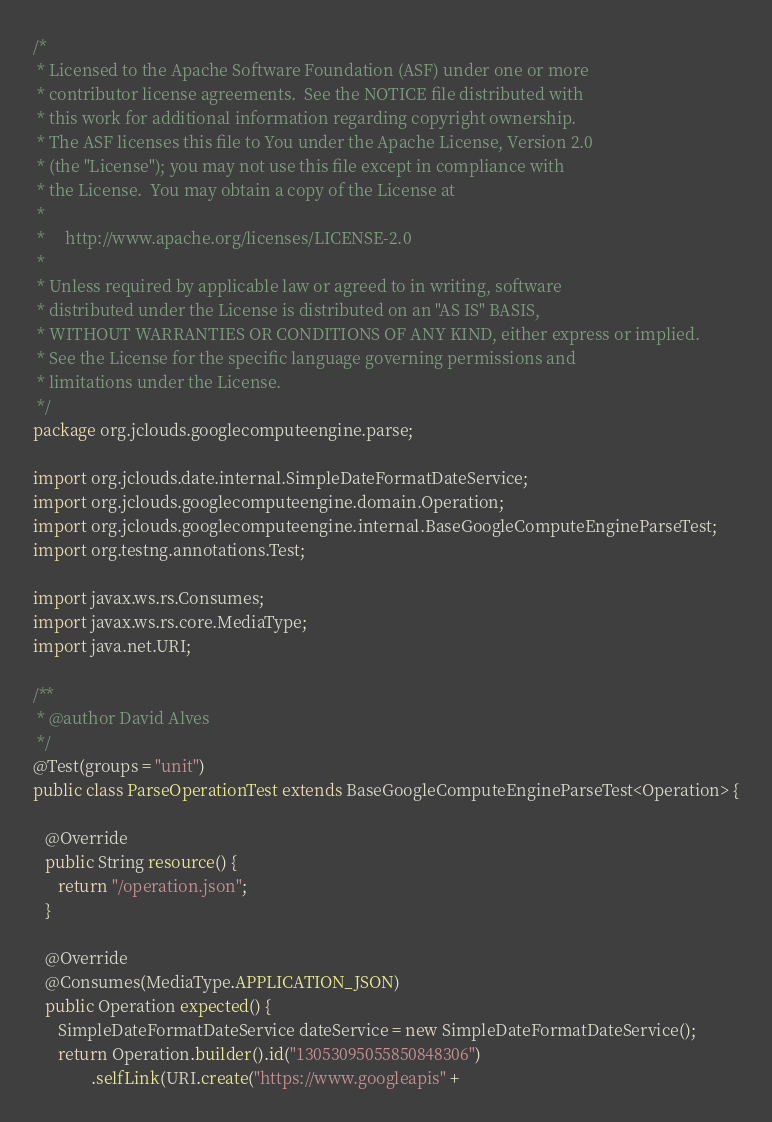<code> <loc_0><loc_0><loc_500><loc_500><_Java_>/*
 * Licensed to the Apache Software Foundation (ASF) under one or more
 * contributor license agreements.  See the NOTICE file distributed with
 * this work for additional information regarding copyright ownership.
 * The ASF licenses this file to You under the Apache License, Version 2.0
 * (the "License"); you may not use this file except in compliance with
 * the License.  You may obtain a copy of the License at
 *
 *     http://www.apache.org/licenses/LICENSE-2.0
 *
 * Unless required by applicable law or agreed to in writing, software
 * distributed under the License is distributed on an "AS IS" BASIS,
 * WITHOUT WARRANTIES OR CONDITIONS OF ANY KIND, either express or implied.
 * See the License for the specific language governing permissions and
 * limitations under the License.
 */
package org.jclouds.googlecomputeengine.parse;

import org.jclouds.date.internal.SimpleDateFormatDateService;
import org.jclouds.googlecomputeengine.domain.Operation;
import org.jclouds.googlecomputeengine.internal.BaseGoogleComputeEngineParseTest;
import org.testng.annotations.Test;

import javax.ws.rs.Consumes;
import javax.ws.rs.core.MediaType;
import java.net.URI;

/**
 * @author David Alves
 */
@Test(groups = "unit")
public class ParseOperationTest extends BaseGoogleComputeEngineParseTest<Operation> {

   @Override
   public String resource() {
      return "/operation.json";
   }

   @Override
   @Consumes(MediaType.APPLICATION_JSON)
   public Operation expected() {
      SimpleDateFormatDateService dateService = new SimpleDateFormatDateService();
      return Operation.builder().id("13053095055850848306")
              .selfLink(URI.create("https://www.googleapis" +</code> 